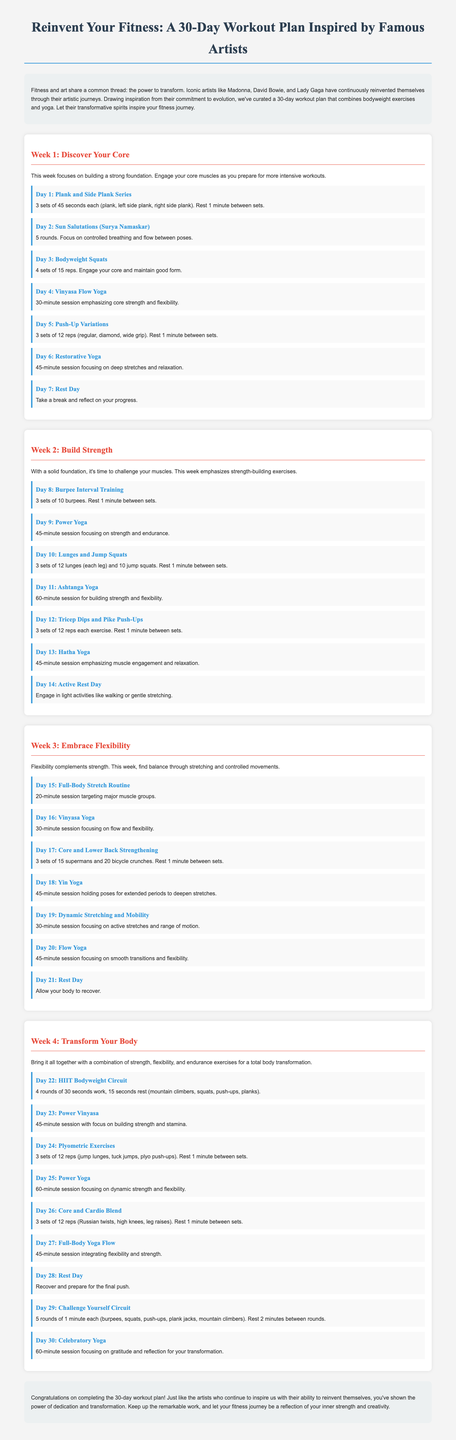What is the title of the workout plan? The title is mentioned at the top of the document, explicitly stating the name of the plan.
Answer: Reinvent Your Fitness: A 30-Day Workout Plan How many weeks are included in the workout plan? The document outlines the structure of the workout plan, including sections specifying each week's focus.
Answer: 4 weeks What type of exercises are primarily used in the plan? The document emphasizes the main type of exercise that forms the foundation of the workout plan.
Answer: Bodyweight exercises and yoga Which day is designated as a rest day in Week 2? The document specifies daily activities, and one of them is identified as a rest day.
Answer: Day 14 How long is the HIIT Bodyweight Circuit workout? The document provides specific time durations for each workout throughout the plan.
Answer: 4 rounds of 30 seconds work, 15 seconds rest What is the focus of Week 3? The document describes the specific theme or objective for activities during Week 3.
Answer: Embrace Flexibility Which artist is mentioned as an inspiration in the introduction? The document references notable artists who influenced the creation of this workout plan.
Answer: Madonna What type of yoga is practiced on Day 19? The document specifies the type of yoga session assigned to that particular day.
Answer: Dynamic Stretching and Mobility 